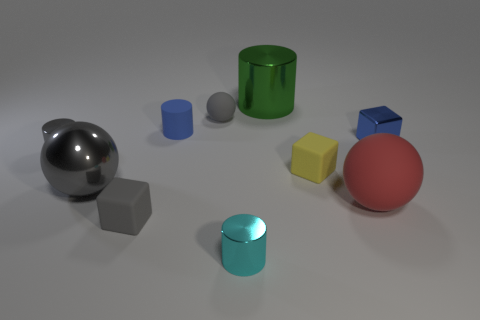What color is the object in front of the block in front of the red matte thing?
Ensure brevity in your answer.  Cyan. There is a large red matte object; what shape is it?
Make the answer very short. Sphere. Does the blue thing right of the green cylinder have the same size as the small cyan cylinder?
Give a very brief answer. Yes. Are there any big purple balls that have the same material as the small cyan cylinder?
Offer a very short reply. No. How many objects are either objects that are in front of the big green shiny cylinder or cyan metal cylinders?
Your answer should be very brief. 9. Are there any tiny purple balls?
Provide a succinct answer. No. What is the shape of the tiny thing that is to the right of the blue matte object and in front of the red sphere?
Ensure brevity in your answer.  Cylinder. There is a rubber sphere that is in front of the blue shiny object; what size is it?
Your answer should be very brief. Large. Does the large metal thing in front of the tiny blue shiny thing have the same color as the tiny sphere?
Your answer should be compact. Yes. What number of tiny green things have the same shape as the large rubber thing?
Provide a short and direct response. 0. 